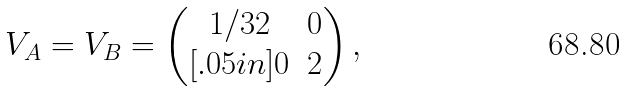<formula> <loc_0><loc_0><loc_500><loc_500>V _ { A } = V _ { B } = \begin{pmatrix} 1 / 3 2 & 0 \\ [ . 0 5 i n ] 0 & 2 \end{pmatrix} ,</formula> 